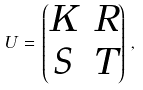Convert formula to latex. <formula><loc_0><loc_0><loc_500><loc_500>U \, = \, \begin{pmatrix} K & R \\ S & T \end{pmatrix} \, ,</formula> 